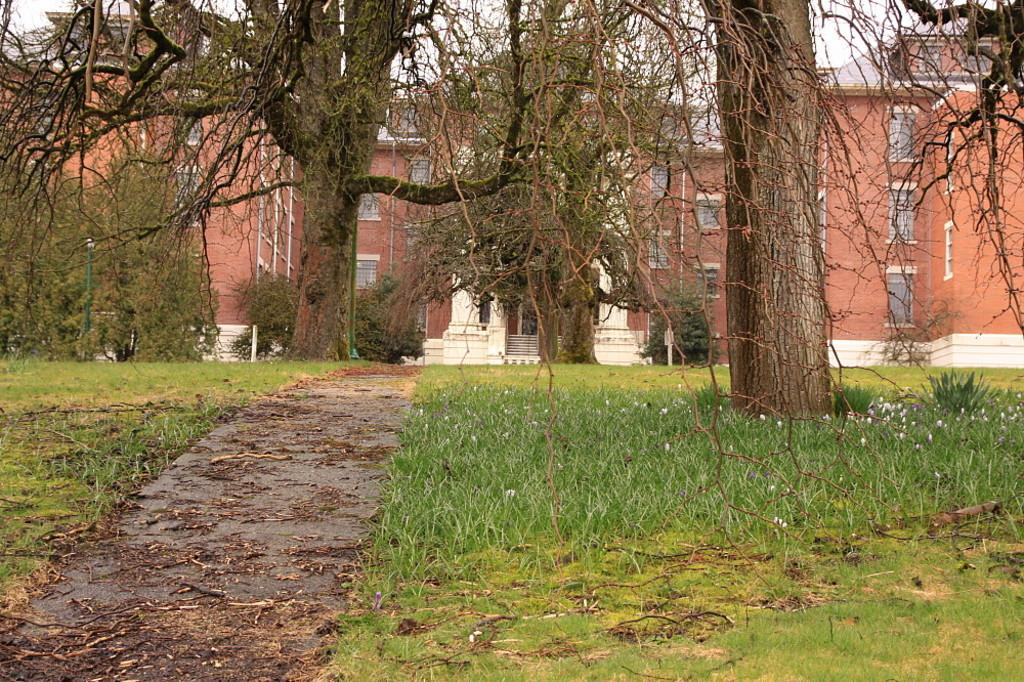What type of vegetation can be seen in the image? There are trees, plants, and grass visible in the image. What kind of pathway is present in the image? There is a walkway in the image. What can be seen in the background of the image? There are buildings and poles in the background of the image. What type of yarn is being used to decorate the throne in the image? There is no throne or yarn present in the image. What type of tail can be seen on the animal in the image? There are no animals with tails present in the image. 